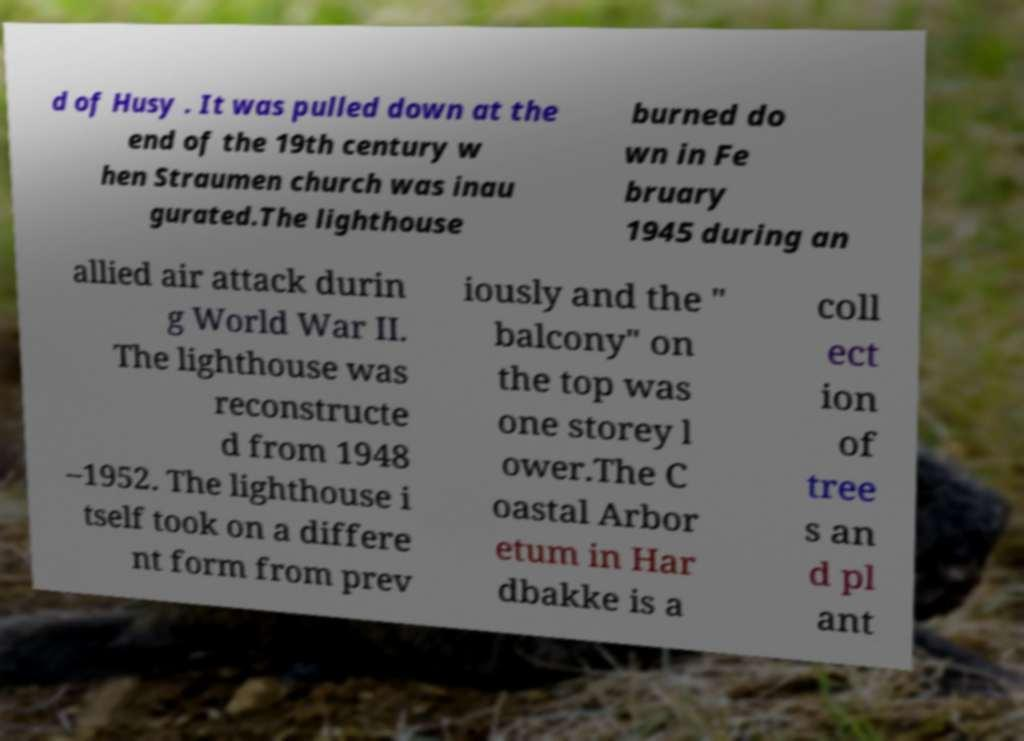Could you extract and type out the text from this image? d of Husy . It was pulled down at the end of the 19th century w hen Straumen church was inau gurated.The lighthouse burned do wn in Fe bruary 1945 during an allied air attack durin g World War II. The lighthouse was reconstructe d from 1948 –1952. The lighthouse i tself took on a differe nt form from prev iously and the " balcony" on the top was one storey l ower.The C oastal Arbor etum in Har dbakke is a coll ect ion of tree s an d pl ant 